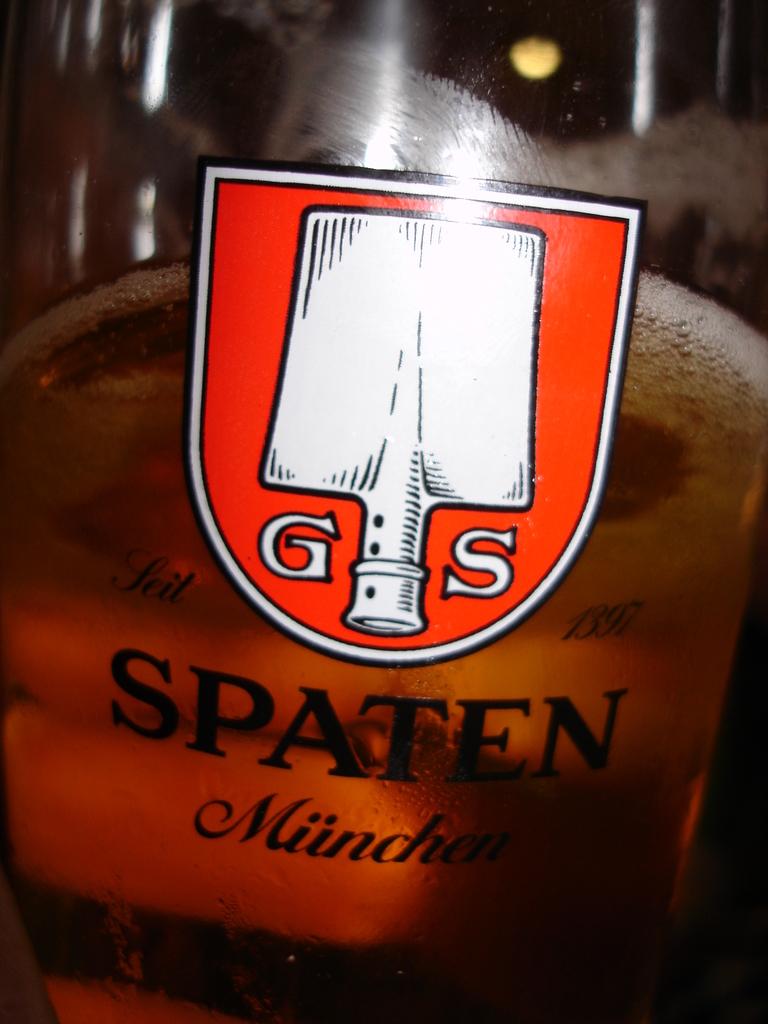What year did spaten start brewing beer?
Ensure brevity in your answer.  1397. What letters are in this companies logo?
Your answer should be compact. Gs. 